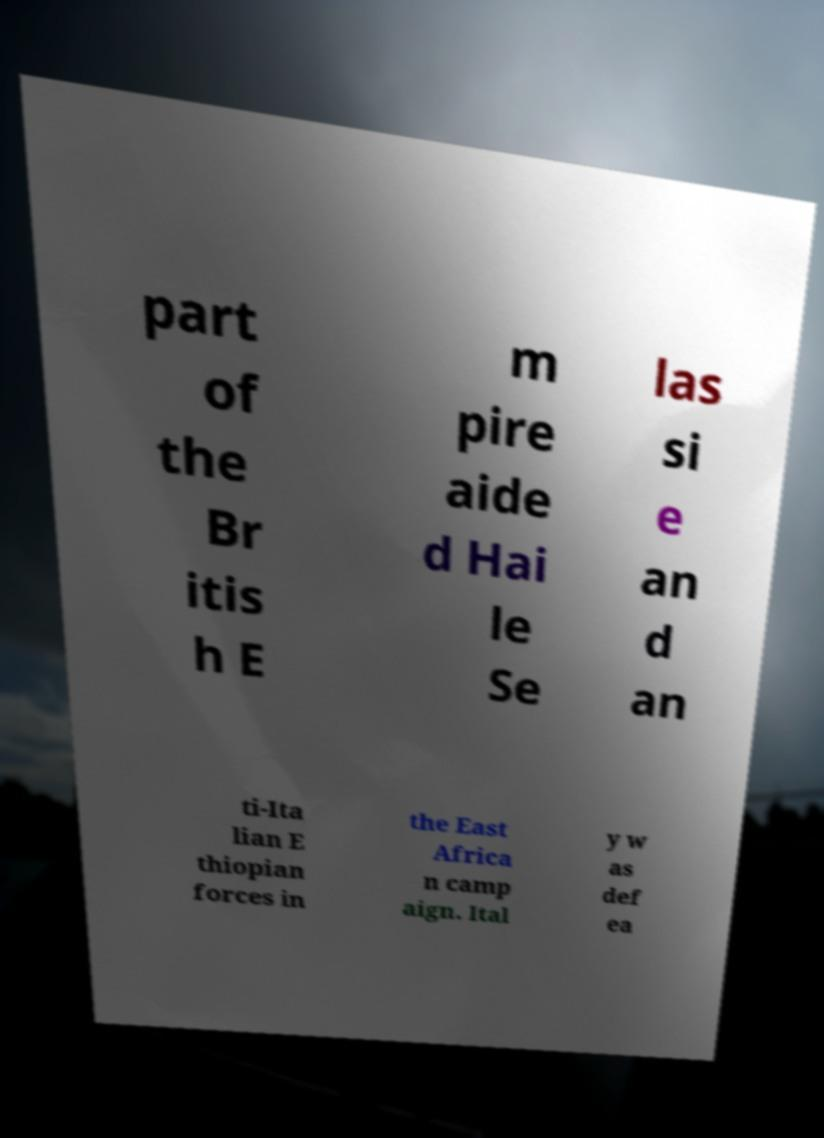What messages or text are displayed in this image? I need them in a readable, typed format. part of the Br itis h E m pire aide d Hai le Se las si e an d an ti-Ita lian E thiopian forces in the East Africa n camp aign. Ital y w as def ea 